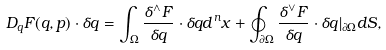<formula> <loc_0><loc_0><loc_500><loc_500>D _ { q } F ( q , p ) \cdot \delta q = \int _ { \Omega } { \frac { \delta ^ { \wedge } F } { \delta q } } \cdot \delta q d ^ { n } x + \oint _ { \partial { \Omega } } { \frac { \delta ^ { \vee } F } { \delta q } } \cdot \delta q | _ { \partial { \Omega } } d S ,</formula> 